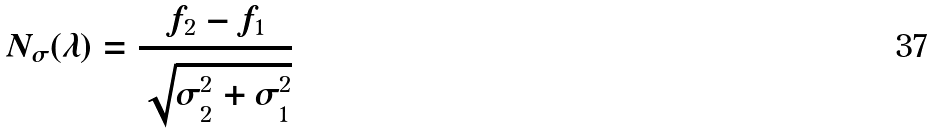<formula> <loc_0><loc_0><loc_500><loc_500>N _ { \sigma } ( \lambda ) = { \frac { f _ { 2 } - f _ { 1 } } { \sqrt { \sigma _ { 2 } ^ { 2 } + \sigma _ { 1 } ^ { 2 } } } }</formula> 